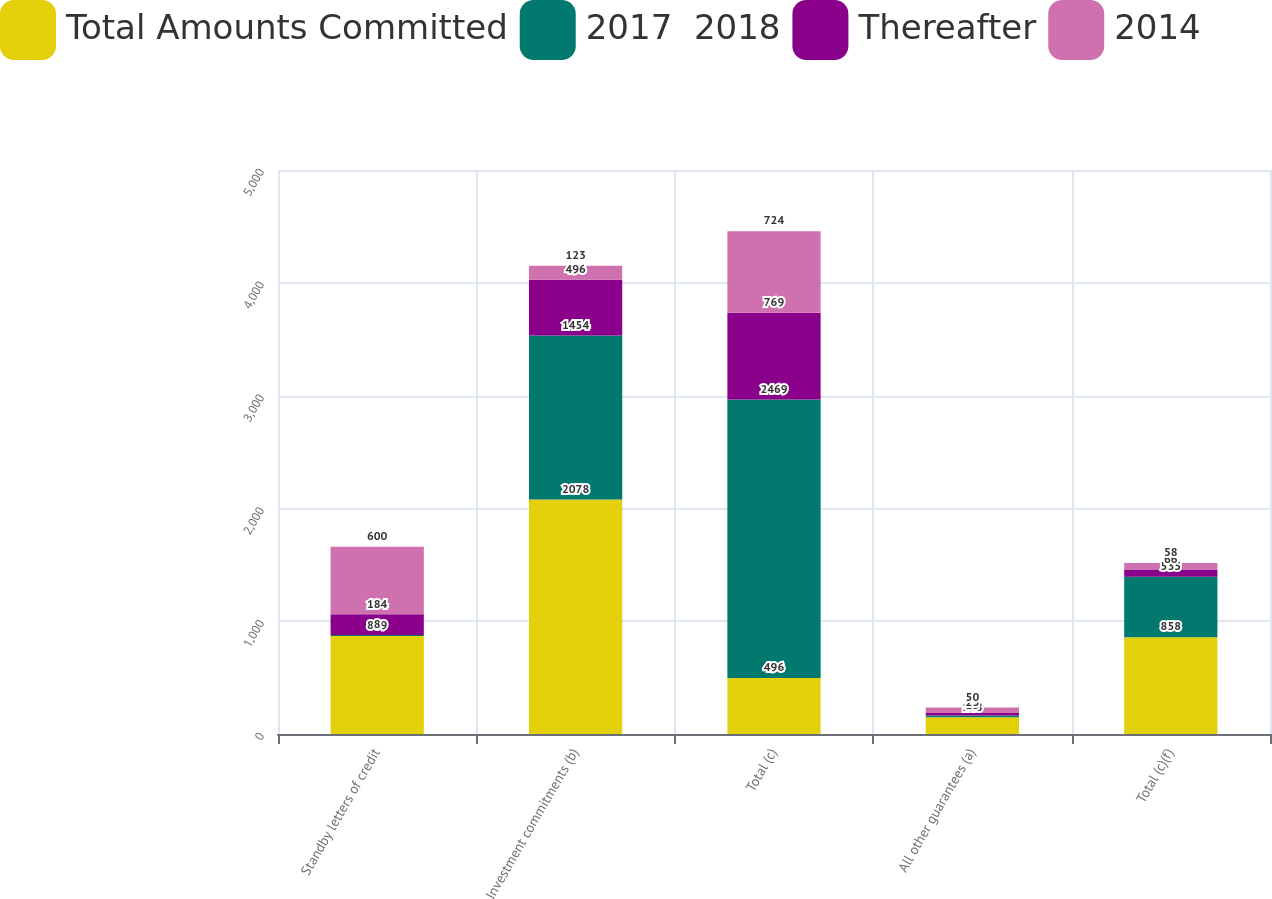Convert chart. <chart><loc_0><loc_0><loc_500><loc_500><stacked_bar_chart><ecel><fcel>Standby letters of credit<fcel>Investment commitments (b)<fcel>Total (c)<fcel>All other guarantees (a)<fcel>Total (c)(f)<nl><fcel>Total Amounts Committed<fcel>869<fcel>2078<fcel>496<fcel>148<fcel>858<nl><fcel>2017  2018<fcel>8<fcel>1454<fcel>2469<fcel>15<fcel>535<nl><fcel>Thereafter<fcel>184<fcel>496<fcel>769<fcel>23<fcel>66<nl><fcel>2014<fcel>600<fcel>123<fcel>724<fcel>50<fcel>58<nl></chart> 